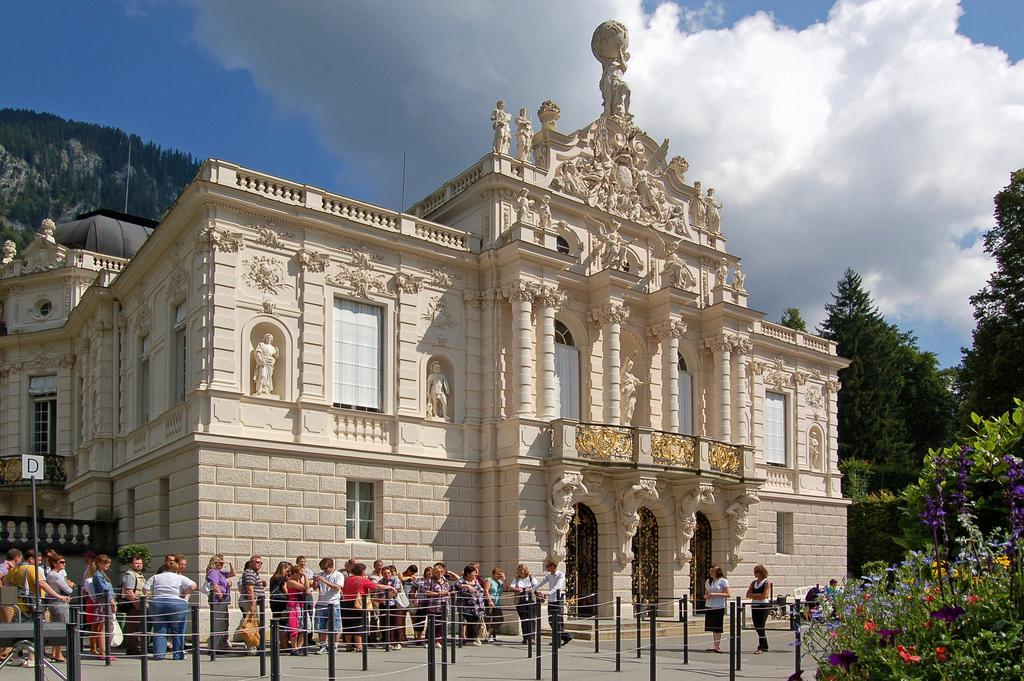How would you summarize this image in a sentence or two? In the picture I can see a building which has sculptures, windows and some other objects. I can also see poles, trees and some other objects. In the background I can see the sky. 